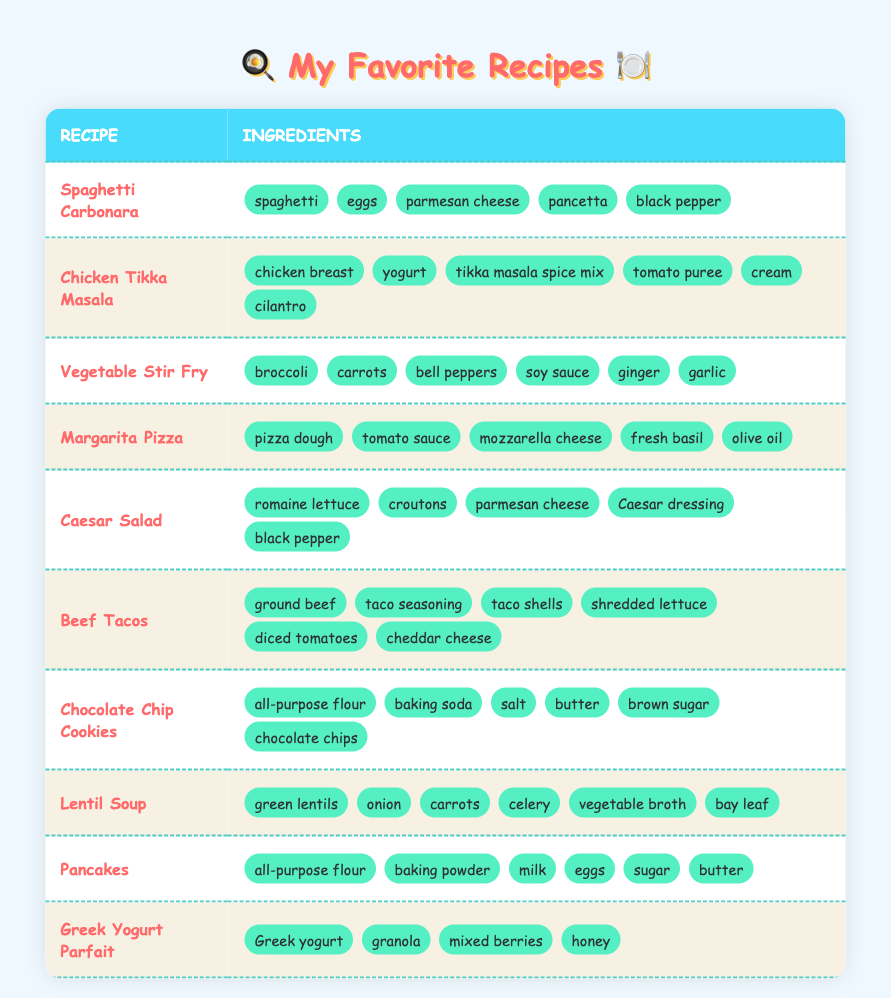What are the ingredients in Spaghetti Carbonara? The ingredients for Spaghetti Carbonara listed in the table include spaghetti, eggs, parmesan cheese, pancetta, and black pepper.
Answer: spaghetti, eggs, parmesan cheese, pancetta, black pepper Which recipe has the ingredient "mozzarella cheese"? By checking the ingredients of each recipe, I find that "mozzarella cheese" is listed under the Margarita Pizza.
Answer: Margarita Pizza How many ingredients are required for Beef Tacos? The Beef Tacos recipe includes six ingredients: ground beef, taco seasoning, taco shells, shredded lettuce, diced tomatoes, and cheddar cheese.
Answer: 6 Is "cream" an ingredient in any of the recipes? Yes, "cream" is an ingredient in the Chicken Tikka Masala recipe.
Answer: Yes Which recipe has the most ingredients listed? I compare the ingredients of all recipes. Chicken Tikka Masala has six ingredients, while others like Spaghetti Carbonara and Caesar Salad have only five. Thus, Chicken Tikka Masala has the most ingredients.
Answer: Chicken Tikka Masala What is the total number of unique ingredients across all recipes? I list each ingredient from all recipes and count unique items. The unique ingredients are spaghetti, eggs, parmesan cheese, pancetta, black pepper, chicken breast, yogurt, tikka masala spice mix, tomato puree, cream, cilantro, broccoli, carrots, bell peppers, soy sauce, ginger, garlic, pizza dough, tomato sauce, mozzarella cheese, fresh basil, olive oil, romaine lettuce, croutons, Caesar dressing, ground beef, taco seasoning, taco shells, shredded lettuce, diced tomatoes, cheddar cheese, all-purpose flour, baking soda, salt, butter, brown sugar, chocolate chips, green lentils, onion, celery, vegetable broth, bay leaf, baking powder, milk, sugar, Greek yogurt, granola, mixed berries, and honey. After counting, there are 43 unique ingredients.
Answer: 43 Do any recipes require baking? Yes, recipes like Chocolate Chip Cookies and Pancakes typically require baking, while others don’t.
Answer: Yes Which recipe uses "vegetable broth" in its ingredients? I find that "vegetable broth" is an ingredient in the Lentil Soup recipe.
Answer: Lentil Soup How many recipes include cheese as an ingredient? I check each recipe for cheese. The recipes that include cheese are: Spaghetti Carbonara (parmesan cheese), Caesar Salad (parmesan cheese), Beef Tacos (cheddar cheese), and Margarita Pizza (mozzarella cheese). Therefore, there are four recipes that include cheese.
Answer: 4 What is the ingredient difference between Chicken Tikka Masala and Vegetable Stir Fry? Chicken Tikka Masala has chicken breast, yogurt, tikka masala spice mix, tomato puree, cream, and cilantro. Vegetable Stir Fry includes broccoli, carrots, bell peppers, soy sauce, ginger, and garlic. Comparing, the two recipes differ in their ingredients, having no overlap and totally distinct ingredients.
Answer: Completely different ingredients 